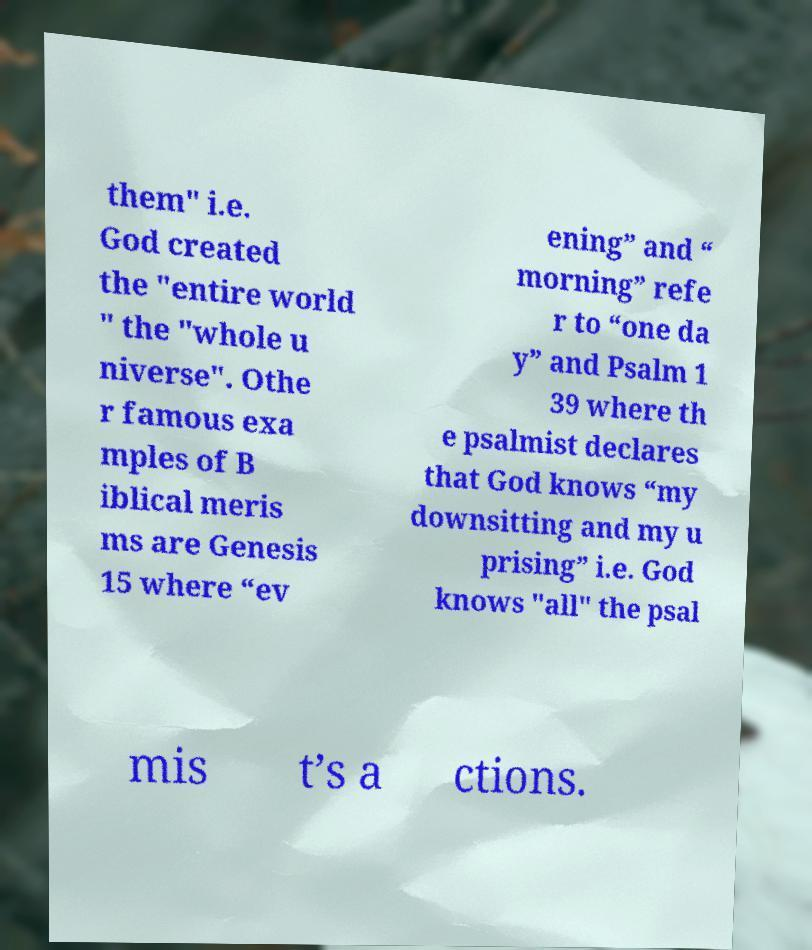For documentation purposes, I need the text within this image transcribed. Could you provide that? them" i.e. God created the "entire world " the "whole u niverse". Othe r famous exa mples of B iblical meris ms are Genesis 15 where “ev ening” and “ morning” refe r to “one da y” and Psalm 1 39 where th e psalmist declares that God knows “my downsitting and my u prising” i.e. God knows "all" the psal mis t’s a ctions. 